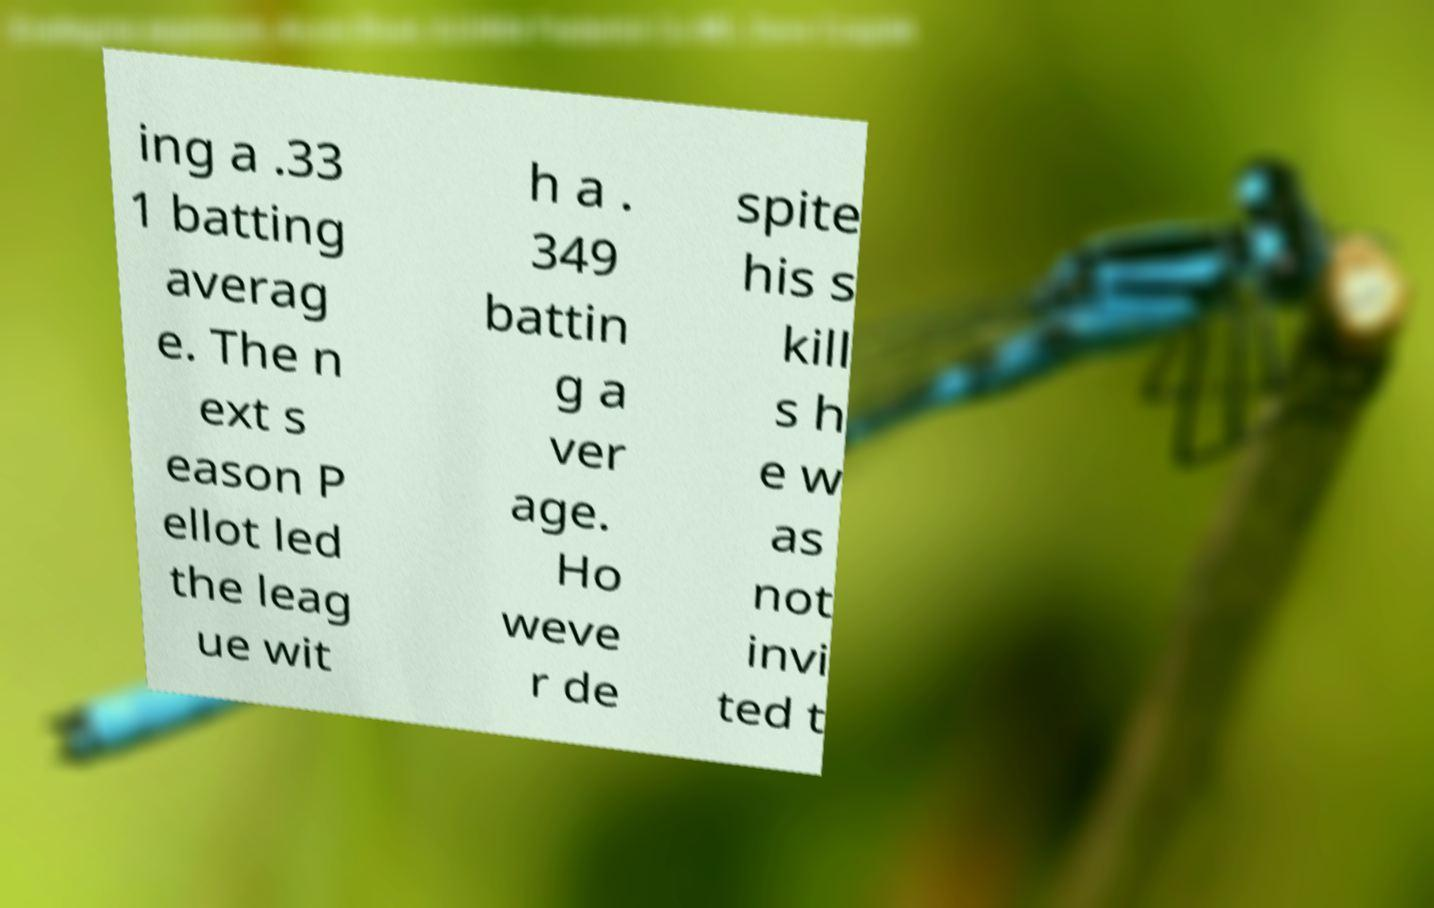Please read and relay the text visible in this image. What does it say? ing a .33 1 batting averag e. The n ext s eason P ellot led the leag ue wit h a . 349 battin g a ver age. Ho weve r de spite his s kill s h e w as not invi ted t 